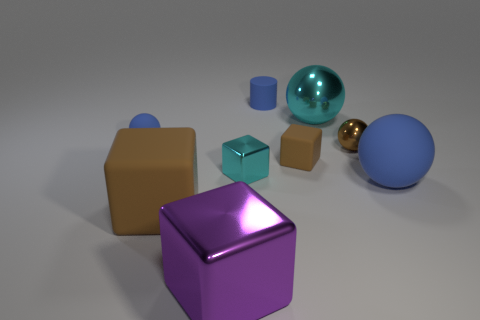Add 1 big purple metallic cylinders. How many objects exist? 10 Subtract all cylinders. How many objects are left? 8 Subtract 1 purple cubes. How many objects are left? 8 Subtract all tiny brown spheres. Subtract all blue cylinders. How many objects are left? 7 Add 5 tiny cylinders. How many tiny cylinders are left? 6 Add 4 yellow blocks. How many yellow blocks exist? 4 